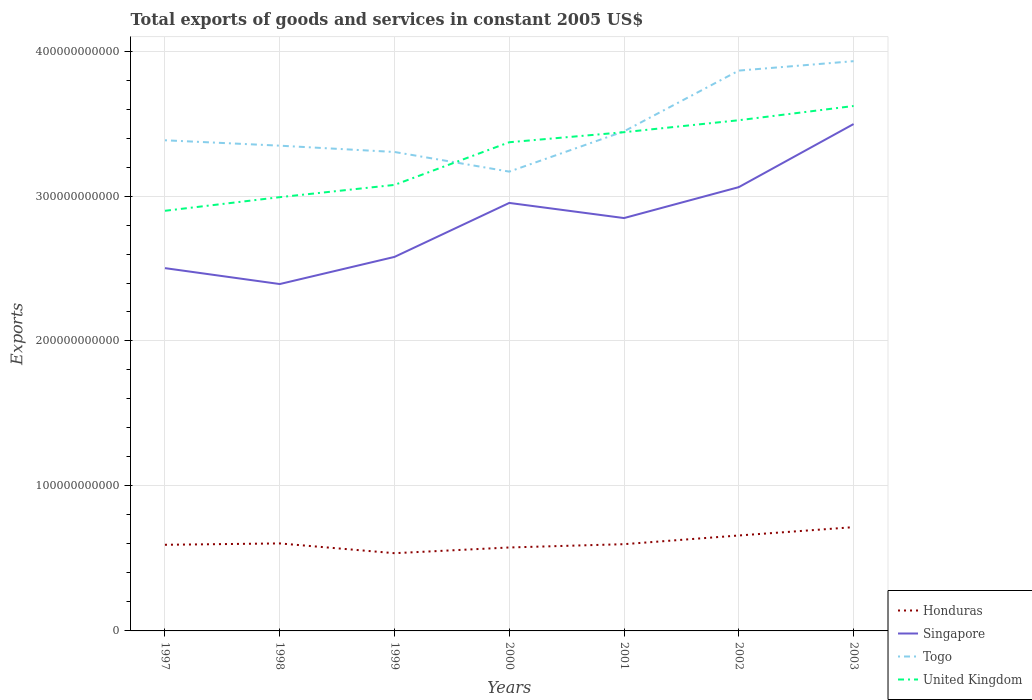Does the line corresponding to Togo intersect with the line corresponding to United Kingdom?
Keep it short and to the point. Yes. Across all years, what is the maximum total exports of goods and services in United Kingdom?
Your response must be concise. 2.90e+11. What is the total total exports of goods and services in Togo in the graph?
Provide a succinct answer. -5.61e+1. What is the difference between the highest and the second highest total exports of goods and services in Singapore?
Your answer should be very brief. 1.10e+11. Is the total exports of goods and services in Honduras strictly greater than the total exports of goods and services in Singapore over the years?
Your answer should be compact. Yes. How many lines are there?
Your response must be concise. 4. How many years are there in the graph?
Provide a short and direct response. 7. What is the difference between two consecutive major ticks on the Y-axis?
Provide a short and direct response. 1.00e+11. Does the graph contain any zero values?
Provide a succinct answer. No. Does the graph contain grids?
Your answer should be compact. Yes. Where does the legend appear in the graph?
Provide a succinct answer. Bottom right. How many legend labels are there?
Make the answer very short. 4. What is the title of the graph?
Your response must be concise. Total exports of goods and services in constant 2005 US$. What is the label or title of the Y-axis?
Offer a terse response. Exports. What is the Exports in Honduras in 1997?
Offer a terse response. 5.94e+1. What is the Exports in Singapore in 1997?
Your answer should be very brief. 2.50e+11. What is the Exports in Togo in 1997?
Your answer should be compact. 3.38e+11. What is the Exports in United Kingdom in 1997?
Provide a succinct answer. 2.90e+11. What is the Exports of Honduras in 1998?
Ensure brevity in your answer.  6.04e+1. What is the Exports of Singapore in 1998?
Keep it short and to the point. 2.39e+11. What is the Exports in Togo in 1998?
Your answer should be compact. 3.35e+11. What is the Exports of United Kingdom in 1998?
Make the answer very short. 2.99e+11. What is the Exports in Honduras in 1999?
Give a very brief answer. 5.36e+1. What is the Exports in Singapore in 1999?
Your answer should be very brief. 2.58e+11. What is the Exports in Togo in 1999?
Offer a very short reply. 3.30e+11. What is the Exports of United Kingdom in 1999?
Ensure brevity in your answer.  3.08e+11. What is the Exports in Honduras in 2000?
Your answer should be very brief. 5.76e+1. What is the Exports in Singapore in 2000?
Ensure brevity in your answer.  2.95e+11. What is the Exports in Togo in 2000?
Provide a short and direct response. 3.17e+11. What is the Exports of United Kingdom in 2000?
Offer a terse response. 3.37e+11. What is the Exports in Honduras in 2001?
Make the answer very short. 5.98e+1. What is the Exports of Singapore in 2001?
Ensure brevity in your answer.  2.85e+11. What is the Exports of Togo in 2001?
Make the answer very short. 3.45e+11. What is the Exports of United Kingdom in 2001?
Offer a very short reply. 3.44e+11. What is the Exports of Honduras in 2002?
Offer a terse response. 6.58e+1. What is the Exports of Singapore in 2002?
Your answer should be very brief. 3.06e+11. What is the Exports of Togo in 2002?
Your answer should be very brief. 3.87e+11. What is the Exports of United Kingdom in 2002?
Your answer should be compact. 3.52e+11. What is the Exports of Honduras in 2003?
Your response must be concise. 7.16e+1. What is the Exports in Singapore in 2003?
Your answer should be compact. 3.50e+11. What is the Exports in Togo in 2003?
Provide a succinct answer. 3.93e+11. What is the Exports of United Kingdom in 2003?
Offer a terse response. 3.62e+11. Across all years, what is the maximum Exports in Honduras?
Your answer should be very brief. 7.16e+1. Across all years, what is the maximum Exports of Singapore?
Make the answer very short. 3.50e+11. Across all years, what is the maximum Exports of Togo?
Give a very brief answer. 3.93e+11. Across all years, what is the maximum Exports in United Kingdom?
Keep it short and to the point. 3.62e+11. Across all years, what is the minimum Exports of Honduras?
Your response must be concise. 5.36e+1. Across all years, what is the minimum Exports in Singapore?
Ensure brevity in your answer.  2.39e+11. Across all years, what is the minimum Exports in Togo?
Give a very brief answer. 3.17e+11. Across all years, what is the minimum Exports in United Kingdom?
Your answer should be compact. 2.90e+11. What is the total Exports of Honduras in the graph?
Provide a succinct answer. 4.28e+11. What is the total Exports of Singapore in the graph?
Offer a very short reply. 1.98e+12. What is the total Exports of Togo in the graph?
Give a very brief answer. 2.44e+12. What is the total Exports of United Kingdom in the graph?
Offer a terse response. 2.29e+12. What is the difference between the Exports of Honduras in 1997 and that in 1998?
Provide a short and direct response. -9.31e+08. What is the difference between the Exports of Singapore in 1997 and that in 1998?
Offer a very short reply. 1.10e+1. What is the difference between the Exports in Togo in 1997 and that in 1998?
Your answer should be very brief. 3.72e+09. What is the difference between the Exports of United Kingdom in 1997 and that in 1998?
Provide a short and direct response. -9.40e+09. What is the difference between the Exports in Honduras in 1997 and that in 1999?
Give a very brief answer. 5.80e+09. What is the difference between the Exports in Singapore in 1997 and that in 1999?
Provide a short and direct response. -7.75e+09. What is the difference between the Exports of Togo in 1997 and that in 1999?
Provide a succinct answer. 8.07e+09. What is the difference between the Exports in United Kingdom in 1997 and that in 1999?
Your answer should be compact. -1.79e+1. What is the difference between the Exports of Honduras in 1997 and that in 2000?
Offer a terse response. 1.86e+09. What is the difference between the Exports of Singapore in 1997 and that in 2000?
Offer a very short reply. -4.50e+1. What is the difference between the Exports of Togo in 1997 and that in 2000?
Your response must be concise. 2.16e+1. What is the difference between the Exports of United Kingdom in 1997 and that in 2000?
Make the answer very short. -4.73e+1. What is the difference between the Exports of Honduras in 1997 and that in 2001?
Your answer should be very brief. -4.18e+08. What is the difference between the Exports of Singapore in 1997 and that in 2001?
Make the answer very short. -3.45e+1. What is the difference between the Exports in Togo in 1997 and that in 2001?
Your answer should be compact. -6.18e+09. What is the difference between the Exports of United Kingdom in 1997 and that in 2001?
Ensure brevity in your answer.  -5.42e+1. What is the difference between the Exports in Honduras in 1997 and that in 2002?
Offer a terse response. -6.41e+09. What is the difference between the Exports in Singapore in 1997 and that in 2002?
Ensure brevity in your answer.  -5.59e+1. What is the difference between the Exports in Togo in 1997 and that in 2002?
Make the answer very short. -4.81e+1. What is the difference between the Exports in United Kingdom in 1997 and that in 2002?
Ensure brevity in your answer.  -6.25e+1. What is the difference between the Exports in Honduras in 1997 and that in 2003?
Ensure brevity in your answer.  -1.22e+1. What is the difference between the Exports of Singapore in 1997 and that in 2003?
Your answer should be very brief. -9.94e+1. What is the difference between the Exports in Togo in 1997 and that in 2003?
Keep it short and to the point. -5.46e+1. What is the difference between the Exports in United Kingdom in 1997 and that in 2003?
Keep it short and to the point. -7.23e+1. What is the difference between the Exports in Honduras in 1998 and that in 1999?
Give a very brief answer. 6.73e+09. What is the difference between the Exports of Singapore in 1998 and that in 1999?
Ensure brevity in your answer.  -1.87e+1. What is the difference between the Exports in Togo in 1998 and that in 1999?
Make the answer very short. 4.35e+09. What is the difference between the Exports of United Kingdom in 1998 and that in 1999?
Keep it short and to the point. -8.45e+09. What is the difference between the Exports in Honduras in 1998 and that in 2000?
Make the answer very short. 2.79e+09. What is the difference between the Exports of Singapore in 1998 and that in 2000?
Make the answer very short. -5.60e+1. What is the difference between the Exports of Togo in 1998 and that in 2000?
Give a very brief answer. 1.79e+1. What is the difference between the Exports in United Kingdom in 1998 and that in 2000?
Your answer should be very brief. -3.79e+1. What is the difference between the Exports of Honduras in 1998 and that in 2001?
Offer a very short reply. 5.13e+08. What is the difference between the Exports in Singapore in 1998 and that in 2001?
Ensure brevity in your answer.  -4.55e+1. What is the difference between the Exports of Togo in 1998 and that in 2001?
Provide a succinct answer. -9.90e+09. What is the difference between the Exports in United Kingdom in 1998 and that in 2001?
Keep it short and to the point. -4.48e+1. What is the difference between the Exports of Honduras in 1998 and that in 2002?
Ensure brevity in your answer.  -5.48e+09. What is the difference between the Exports in Singapore in 1998 and that in 2002?
Offer a very short reply. -6.69e+1. What is the difference between the Exports in Togo in 1998 and that in 2002?
Provide a short and direct response. -5.18e+1. What is the difference between the Exports of United Kingdom in 1998 and that in 2002?
Provide a succinct answer. -5.31e+1. What is the difference between the Exports of Honduras in 1998 and that in 2003?
Provide a short and direct response. -1.12e+1. What is the difference between the Exports of Singapore in 1998 and that in 2003?
Provide a succinct answer. -1.10e+11. What is the difference between the Exports of Togo in 1998 and that in 2003?
Offer a very short reply. -5.83e+1. What is the difference between the Exports of United Kingdom in 1998 and that in 2003?
Offer a terse response. -6.29e+1. What is the difference between the Exports in Honduras in 1999 and that in 2000?
Provide a short and direct response. -3.94e+09. What is the difference between the Exports in Singapore in 1999 and that in 2000?
Provide a succinct answer. -3.72e+1. What is the difference between the Exports of Togo in 1999 and that in 2000?
Give a very brief answer. 1.35e+1. What is the difference between the Exports of United Kingdom in 1999 and that in 2000?
Make the answer very short. -2.94e+1. What is the difference between the Exports of Honduras in 1999 and that in 2001?
Provide a short and direct response. -6.22e+09. What is the difference between the Exports of Singapore in 1999 and that in 2001?
Your response must be concise. -2.68e+1. What is the difference between the Exports of Togo in 1999 and that in 2001?
Make the answer very short. -1.43e+1. What is the difference between the Exports in United Kingdom in 1999 and that in 2001?
Provide a short and direct response. -3.64e+1. What is the difference between the Exports in Honduras in 1999 and that in 2002?
Provide a succinct answer. -1.22e+1. What is the difference between the Exports in Singapore in 1999 and that in 2002?
Your answer should be very brief. -4.81e+1. What is the difference between the Exports in Togo in 1999 and that in 2002?
Offer a terse response. -5.61e+1. What is the difference between the Exports in United Kingdom in 1999 and that in 2002?
Your answer should be compact. -4.46e+1. What is the difference between the Exports of Honduras in 1999 and that in 2003?
Provide a short and direct response. -1.80e+1. What is the difference between the Exports in Singapore in 1999 and that in 2003?
Offer a terse response. -9.16e+1. What is the difference between the Exports in Togo in 1999 and that in 2003?
Make the answer very short. -6.26e+1. What is the difference between the Exports in United Kingdom in 1999 and that in 2003?
Provide a short and direct response. -5.44e+1. What is the difference between the Exports of Honduras in 2000 and that in 2001?
Offer a terse response. -2.28e+09. What is the difference between the Exports of Singapore in 2000 and that in 2001?
Keep it short and to the point. 1.04e+1. What is the difference between the Exports in Togo in 2000 and that in 2001?
Give a very brief answer. -2.78e+1. What is the difference between the Exports in United Kingdom in 2000 and that in 2001?
Make the answer very short. -6.93e+09. What is the difference between the Exports in Honduras in 2000 and that in 2002?
Your response must be concise. -8.27e+09. What is the difference between the Exports in Singapore in 2000 and that in 2002?
Give a very brief answer. -1.09e+1. What is the difference between the Exports of Togo in 2000 and that in 2002?
Keep it short and to the point. -6.97e+1. What is the difference between the Exports of United Kingdom in 2000 and that in 2002?
Offer a terse response. -1.52e+1. What is the difference between the Exports in Honduras in 2000 and that in 2003?
Your answer should be compact. -1.40e+1. What is the difference between the Exports of Singapore in 2000 and that in 2003?
Your answer should be compact. -5.44e+1. What is the difference between the Exports of Togo in 2000 and that in 2003?
Offer a very short reply. -7.62e+1. What is the difference between the Exports of United Kingdom in 2000 and that in 2003?
Your response must be concise. -2.50e+1. What is the difference between the Exports in Honduras in 2001 and that in 2002?
Your answer should be compact. -5.99e+09. What is the difference between the Exports in Singapore in 2001 and that in 2002?
Your answer should be very brief. -2.13e+1. What is the difference between the Exports of Togo in 2001 and that in 2002?
Give a very brief answer. -4.19e+1. What is the difference between the Exports in United Kingdom in 2001 and that in 2002?
Ensure brevity in your answer.  -8.25e+09. What is the difference between the Exports of Honduras in 2001 and that in 2003?
Offer a terse response. -1.17e+1. What is the difference between the Exports in Singapore in 2001 and that in 2003?
Offer a terse response. -6.49e+1. What is the difference between the Exports in Togo in 2001 and that in 2003?
Offer a very short reply. -4.84e+1. What is the difference between the Exports in United Kingdom in 2001 and that in 2003?
Your answer should be very brief. -1.81e+1. What is the difference between the Exports in Honduras in 2002 and that in 2003?
Your answer should be very brief. -5.75e+09. What is the difference between the Exports of Singapore in 2002 and that in 2003?
Offer a very short reply. -4.35e+1. What is the difference between the Exports of Togo in 2002 and that in 2003?
Ensure brevity in your answer.  -6.49e+09. What is the difference between the Exports of United Kingdom in 2002 and that in 2003?
Offer a very short reply. -9.82e+09. What is the difference between the Exports of Honduras in 1997 and the Exports of Singapore in 1998?
Offer a terse response. -1.80e+11. What is the difference between the Exports in Honduras in 1997 and the Exports in Togo in 1998?
Your response must be concise. -2.75e+11. What is the difference between the Exports of Honduras in 1997 and the Exports of United Kingdom in 1998?
Ensure brevity in your answer.  -2.40e+11. What is the difference between the Exports of Singapore in 1997 and the Exports of Togo in 1998?
Keep it short and to the point. -8.45e+1. What is the difference between the Exports in Singapore in 1997 and the Exports in United Kingdom in 1998?
Your answer should be very brief. -4.90e+1. What is the difference between the Exports in Togo in 1997 and the Exports in United Kingdom in 1998?
Provide a short and direct response. 3.92e+1. What is the difference between the Exports in Honduras in 1997 and the Exports in Singapore in 1999?
Ensure brevity in your answer.  -1.99e+11. What is the difference between the Exports in Honduras in 1997 and the Exports in Togo in 1999?
Give a very brief answer. -2.71e+11. What is the difference between the Exports of Honduras in 1997 and the Exports of United Kingdom in 1999?
Give a very brief answer. -2.48e+11. What is the difference between the Exports in Singapore in 1997 and the Exports in Togo in 1999?
Ensure brevity in your answer.  -8.01e+1. What is the difference between the Exports of Singapore in 1997 and the Exports of United Kingdom in 1999?
Offer a terse response. -5.74e+1. What is the difference between the Exports in Togo in 1997 and the Exports in United Kingdom in 1999?
Your answer should be very brief. 3.08e+1. What is the difference between the Exports of Honduras in 1997 and the Exports of Singapore in 2000?
Your response must be concise. -2.36e+11. What is the difference between the Exports in Honduras in 1997 and the Exports in Togo in 2000?
Offer a terse response. -2.57e+11. What is the difference between the Exports in Honduras in 1997 and the Exports in United Kingdom in 2000?
Provide a short and direct response. -2.78e+11. What is the difference between the Exports in Singapore in 1997 and the Exports in Togo in 2000?
Your response must be concise. -6.66e+1. What is the difference between the Exports of Singapore in 1997 and the Exports of United Kingdom in 2000?
Your answer should be very brief. -8.68e+1. What is the difference between the Exports of Togo in 1997 and the Exports of United Kingdom in 2000?
Keep it short and to the point. 1.35e+09. What is the difference between the Exports in Honduras in 1997 and the Exports in Singapore in 2001?
Ensure brevity in your answer.  -2.25e+11. What is the difference between the Exports in Honduras in 1997 and the Exports in Togo in 2001?
Your answer should be compact. -2.85e+11. What is the difference between the Exports of Honduras in 1997 and the Exports of United Kingdom in 2001?
Offer a terse response. -2.85e+11. What is the difference between the Exports of Singapore in 1997 and the Exports of Togo in 2001?
Make the answer very short. -9.44e+1. What is the difference between the Exports of Singapore in 1997 and the Exports of United Kingdom in 2001?
Provide a succinct answer. -9.38e+1. What is the difference between the Exports of Togo in 1997 and the Exports of United Kingdom in 2001?
Keep it short and to the point. -5.58e+09. What is the difference between the Exports in Honduras in 1997 and the Exports in Singapore in 2002?
Keep it short and to the point. -2.47e+11. What is the difference between the Exports in Honduras in 1997 and the Exports in Togo in 2002?
Offer a very short reply. -3.27e+11. What is the difference between the Exports of Honduras in 1997 and the Exports of United Kingdom in 2002?
Your answer should be very brief. -2.93e+11. What is the difference between the Exports of Singapore in 1997 and the Exports of Togo in 2002?
Offer a very short reply. -1.36e+11. What is the difference between the Exports of Singapore in 1997 and the Exports of United Kingdom in 2002?
Your response must be concise. -1.02e+11. What is the difference between the Exports of Togo in 1997 and the Exports of United Kingdom in 2002?
Make the answer very short. -1.38e+1. What is the difference between the Exports in Honduras in 1997 and the Exports in Singapore in 2003?
Provide a short and direct response. -2.90e+11. What is the difference between the Exports in Honduras in 1997 and the Exports in Togo in 2003?
Make the answer very short. -3.34e+11. What is the difference between the Exports in Honduras in 1997 and the Exports in United Kingdom in 2003?
Offer a terse response. -3.03e+11. What is the difference between the Exports in Singapore in 1997 and the Exports in Togo in 2003?
Make the answer very short. -1.43e+11. What is the difference between the Exports of Singapore in 1997 and the Exports of United Kingdom in 2003?
Give a very brief answer. -1.12e+11. What is the difference between the Exports of Togo in 1997 and the Exports of United Kingdom in 2003?
Provide a succinct answer. -2.36e+1. What is the difference between the Exports of Honduras in 1998 and the Exports of Singapore in 1999?
Provide a succinct answer. -1.98e+11. What is the difference between the Exports of Honduras in 1998 and the Exports of Togo in 1999?
Offer a terse response. -2.70e+11. What is the difference between the Exports in Honduras in 1998 and the Exports in United Kingdom in 1999?
Your answer should be compact. -2.47e+11. What is the difference between the Exports in Singapore in 1998 and the Exports in Togo in 1999?
Ensure brevity in your answer.  -9.11e+1. What is the difference between the Exports in Singapore in 1998 and the Exports in United Kingdom in 1999?
Your answer should be compact. -6.84e+1. What is the difference between the Exports of Togo in 1998 and the Exports of United Kingdom in 1999?
Offer a terse response. 2.71e+1. What is the difference between the Exports in Honduras in 1998 and the Exports in Singapore in 2000?
Give a very brief answer. -2.35e+11. What is the difference between the Exports of Honduras in 1998 and the Exports of Togo in 2000?
Your answer should be compact. -2.56e+11. What is the difference between the Exports of Honduras in 1998 and the Exports of United Kingdom in 2000?
Offer a very short reply. -2.77e+11. What is the difference between the Exports in Singapore in 1998 and the Exports in Togo in 2000?
Give a very brief answer. -7.76e+1. What is the difference between the Exports in Singapore in 1998 and the Exports in United Kingdom in 2000?
Give a very brief answer. -9.78e+1. What is the difference between the Exports of Togo in 1998 and the Exports of United Kingdom in 2000?
Give a very brief answer. -2.37e+09. What is the difference between the Exports of Honduras in 1998 and the Exports of Singapore in 2001?
Offer a very short reply. -2.24e+11. What is the difference between the Exports of Honduras in 1998 and the Exports of Togo in 2001?
Your answer should be very brief. -2.84e+11. What is the difference between the Exports of Honduras in 1998 and the Exports of United Kingdom in 2001?
Provide a short and direct response. -2.84e+11. What is the difference between the Exports of Singapore in 1998 and the Exports of Togo in 2001?
Give a very brief answer. -1.05e+11. What is the difference between the Exports in Singapore in 1998 and the Exports in United Kingdom in 2001?
Give a very brief answer. -1.05e+11. What is the difference between the Exports in Togo in 1998 and the Exports in United Kingdom in 2001?
Keep it short and to the point. -9.30e+09. What is the difference between the Exports of Honduras in 1998 and the Exports of Singapore in 2002?
Ensure brevity in your answer.  -2.46e+11. What is the difference between the Exports of Honduras in 1998 and the Exports of Togo in 2002?
Provide a succinct answer. -3.26e+11. What is the difference between the Exports of Honduras in 1998 and the Exports of United Kingdom in 2002?
Your answer should be compact. -2.92e+11. What is the difference between the Exports in Singapore in 1998 and the Exports in Togo in 2002?
Give a very brief answer. -1.47e+11. What is the difference between the Exports in Singapore in 1998 and the Exports in United Kingdom in 2002?
Give a very brief answer. -1.13e+11. What is the difference between the Exports in Togo in 1998 and the Exports in United Kingdom in 2002?
Offer a very short reply. -1.76e+1. What is the difference between the Exports of Honduras in 1998 and the Exports of Singapore in 2003?
Your answer should be compact. -2.89e+11. What is the difference between the Exports of Honduras in 1998 and the Exports of Togo in 2003?
Provide a succinct answer. -3.33e+11. What is the difference between the Exports of Honduras in 1998 and the Exports of United Kingdom in 2003?
Provide a succinct answer. -3.02e+11. What is the difference between the Exports in Singapore in 1998 and the Exports in Togo in 2003?
Offer a very short reply. -1.54e+11. What is the difference between the Exports in Singapore in 1998 and the Exports in United Kingdom in 2003?
Offer a terse response. -1.23e+11. What is the difference between the Exports in Togo in 1998 and the Exports in United Kingdom in 2003?
Your answer should be very brief. -2.74e+1. What is the difference between the Exports of Honduras in 1999 and the Exports of Singapore in 2000?
Provide a short and direct response. -2.42e+11. What is the difference between the Exports in Honduras in 1999 and the Exports in Togo in 2000?
Offer a terse response. -2.63e+11. What is the difference between the Exports in Honduras in 1999 and the Exports in United Kingdom in 2000?
Make the answer very short. -2.83e+11. What is the difference between the Exports of Singapore in 1999 and the Exports of Togo in 2000?
Your answer should be compact. -5.88e+1. What is the difference between the Exports of Singapore in 1999 and the Exports of United Kingdom in 2000?
Ensure brevity in your answer.  -7.91e+1. What is the difference between the Exports in Togo in 1999 and the Exports in United Kingdom in 2000?
Your answer should be very brief. -6.72e+09. What is the difference between the Exports in Honduras in 1999 and the Exports in Singapore in 2001?
Your answer should be very brief. -2.31e+11. What is the difference between the Exports in Honduras in 1999 and the Exports in Togo in 2001?
Your answer should be very brief. -2.91e+11. What is the difference between the Exports in Honduras in 1999 and the Exports in United Kingdom in 2001?
Offer a very short reply. -2.90e+11. What is the difference between the Exports in Singapore in 1999 and the Exports in Togo in 2001?
Your response must be concise. -8.66e+1. What is the difference between the Exports of Singapore in 1999 and the Exports of United Kingdom in 2001?
Keep it short and to the point. -8.60e+1. What is the difference between the Exports in Togo in 1999 and the Exports in United Kingdom in 2001?
Make the answer very short. -1.37e+1. What is the difference between the Exports in Honduras in 1999 and the Exports in Singapore in 2002?
Provide a short and direct response. -2.53e+11. What is the difference between the Exports of Honduras in 1999 and the Exports of Togo in 2002?
Offer a terse response. -3.33e+11. What is the difference between the Exports in Honduras in 1999 and the Exports in United Kingdom in 2002?
Your answer should be very brief. -2.99e+11. What is the difference between the Exports of Singapore in 1999 and the Exports of Togo in 2002?
Your answer should be compact. -1.29e+11. What is the difference between the Exports of Singapore in 1999 and the Exports of United Kingdom in 2002?
Your answer should be very brief. -9.43e+1. What is the difference between the Exports in Togo in 1999 and the Exports in United Kingdom in 2002?
Your response must be concise. -2.19e+1. What is the difference between the Exports of Honduras in 1999 and the Exports of Singapore in 2003?
Your answer should be very brief. -2.96e+11. What is the difference between the Exports in Honduras in 1999 and the Exports in Togo in 2003?
Give a very brief answer. -3.39e+11. What is the difference between the Exports in Honduras in 1999 and the Exports in United Kingdom in 2003?
Offer a terse response. -3.08e+11. What is the difference between the Exports of Singapore in 1999 and the Exports of Togo in 2003?
Provide a succinct answer. -1.35e+11. What is the difference between the Exports of Singapore in 1999 and the Exports of United Kingdom in 2003?
Your answer should be very brief. -1.04e+11. What is the difference between the Exports of Togo in 1999 and the Exports of United Kingdom in 2003?
Give a very brief answer. -3.17e+1. What is the difference between the Exports in Honduras in 2000 and the Exports in Singapore in 2001?
Offer a very short reply. -2.27e+11. What is the difference between the Exports in Honduras in 2000 and the Exports in Togo in 2001?
Offer a terse response. -2.87e+11. What is the difference between the Exports of Honduras in 2000 and the Exports of United Kingdom in 2001?
Offer a terse response. -2.86e+11. What is the difference between the Exports of Singapore in 2000 and the Exports of Togo in 2001?
Your answer should be compact. -4.94e+1. What is the difference between the Exports of Singapore in 2000 and the Exports of United Kingdom in 2001?
Provide a succinct answer. -4.88e+1. What is the difference between the Exports in Togo in 2000 and the Exports in United Kingdom in 2001?
Your answer should be compact. -2.72e+1. What is the difference between the Exports of Honduras in 2000 and the Exports of Singapore in 2002?
Your answer should be very brief. -2.49e+11. What is the difference between the Exports in Honduras in 2000 and the Exports in Togo in 2002?
Your response must be concise. -3.29e+11. What is the difference between the Exports of Honduras in 2000 and the Exports of United Kingdom in 2002?
Offer a terse response. -2.95e+11. What is the difference between the Exports of Singapore in 2000 and the Exports of Togo in 2002?
Your response must be concise. -9.13e+1. What is the difference between the Exports in Singapore in 2000 and the Exports in United Kingdom in 2002?
Give a very brief answer. -5.70e+1. What is the difference between the Exports of Togo in 2000 and the Exports of United Kingdom in 2002?
Keep it short and to the point. -3.54e+1. What is the difference between the Exports of Honduras in 2000 and the Exports of Singapore in 2003?
Offer a very short reply. -2.92e+11. What is the difference between the Exports in Honduras in 2000 and the Exports in Togo in 2003?
Your response must be concise. -3.35e+11. What is the difference between the Exports in Honduras in 2000 and the Exports in United Kingdom in 2003?
Provide a succinct answer. -3.05e+11. What is the difference between the Exports of Singapore in 2000 and the Exports of Togo in 2003?
Your answer should be very brief. -9.78e+1. What is the difference between the Exports in Singapore in 2000 and the Exports in United Kingdom in 2003?
Your response must be concise. -6.69e+1. What is the difference between the Exports in Togo in 2000 and the Exports in United Kingdom in 2003?
Make the answer very short. -4.53e+1. What is the difference between the Exports in Honduras in 2001 and the Exports in Singapore in 2002?
Your answer should be compact. -2.46e+11. What is the difference between the Exports in Honduras in 2001 and the Exports in Togo in 2002?
Offer a terse response. -3.27e+11. What is the difference between the Exports in Honduras in 2001 and the Exports in United Kingdom in 2002?
Your response must be concise. -2.92e+11. What is the difference between the Exports in Singapore in 2001 and the Exports in Togo in 2002?
Provide a succinct answer. -1.02e+11. What is the difference between the Exports in Singapore in 2001 and the Exports in United Kingdom in 2002?
Your answer should be very brief. -6.75e+1. What is the difference between the Exports in Togo in 2001 and the Exports in United Kingdom in 2002?
Offer a very short reply. -7.65e+09. What is the difference between the Exports in Honduras in 2001 and the Exports in Singapore in 2003?
Offer a terse response. -2.90e+11. What is the difference between the Exports in Honduras in 2001 and the Exports in Togo in 2003?
Your response must be concise. -3.33e+11. What is the difference between the Exports in Honduras in 2001 and the Exports in United Kingdom in 2003?
Make the answer very short. -3.02e+11. What is the difference between the Exports of Singapore in 2001 and the Exports of Togo in 2003?
Your answer should be very brief. -1.08e+11. What is the difference between the Exports of Singapore in 2001 and the Exports of United Kingdom in 2003?
Keep it short and to the point. -7.73e+1. What is the difference between the Exports of Togo in 2001 and the Exports of United Kingdom in 2003?
Ensure brevity in your answer.  -1.75e+1. What is the difference between the Exports in Honduras in 2002 and the Exports in Singapore in 2003?
Keep it short and to the point. -2.84e+11. What is the difference between the Exports of Honduras in 2002 and the Exports of Togo in 2003?
Keep it short and to the point. -3.27e+11. What is the difference between the Exports in Honduras in 2002 and the Exports in United Kingdom in 2003?
Make the answer very short. -2.96e+11. What is the difference between the Exports in Singapore in 2002 and the Exports in Togo in 2003?
Your response must be concise. -8.69e+1. What is the difference between the Exports of Singapore in 2002 and the Exports of United Kingdom in 2003?
Offer a very short reply. -5.60e+1. What is the difference between the Exports of Togo in 2002 and the Exports of United Kingdom in 2003?
Provide a short and direct response. 2.44e+1. What is the average Exports in Honduras per year?
Provide a succinct answer. 6.12e+1. What is the average Exports of Singapore per year?
Ensure brevity in your answer.  2.83e+11. What is the average Exports of Togo per year?
Your answer should be compact. 3.49e+11. What is the average Exports in United Kingdom per year?
Provide a succinct answer. 3.27e+11. In the year 1997, what is the difference between the Exports in Honduras and Exports in Singapore?
Ensure brevity in your answer.  -1.91e+11. In the year 1997, what is the difference between the Exports in Honduras and Exports in Togo?
Keep it short and to the point. -2.79e+11. In the year 1997, what is the difference between the Exports in Honduras and Exports in United Kingdom?
Ensure brevity in your answer.  -2.30e+11. In the year 1997, what is the difference between the Exports of Singapore and Exports of Togo?
Keep it short and to the point. -8.82e+1. In the year 1997, what is the difference between the Exports of Singapore and Exports of United Kingdom?
Keep it short and to the point. -3.96e+1. In the year 1997, what is the difference between the Exports of Togo and Exports of United Kingdom?
Make the answer very short. 4.86e+1. In the year 1998, what is the difference between the Exports in Honduras and Exports in Singapore?
Your answer should be very brief. -1.79e+11. In the year 1998, what is the difference between the Exports of Honduras and Exports of Togo?
Your answer should be compact. -2.74e+11. In the year 1998, what is the difference between the Exports in Honduras and Exports in United Kingdom?
Your answer should be very brief. -2.39e+11. In the year 1998, what is the difference between the Exports in Singapore and Exports in Togo?
Give a very brief answer. -9.55e+1. In the year 1998, what is the difference between the Exports of Singapore and Exports of United Kingdom?
Provide a succinct answer. -5.99e+1. In the year 1998, what is the difference between the Exports of Togo and Exports of United Kingdom?
Provide a short and direct response. 3.55e+1. In the year 1999, what is the difference between the Exports of Honduras and Exports of Singapore?
Make the answer very short. -2.04e+11. In the year 1999, what is the difference between the Exports in Honduras and Exports in Togo?
Your answer should be compact. -2.77e+11. In the year 1999, what is the difference between the Exports in Honduras and Exports in United Kingdom?
Your answer should be compact. -2.54e+11. In the year 1999, what is the difference between the Exports in Singapore and Exports in Togo?
Keep it short and to the point. -7.24e+1. In the year 1999, what is the difference between the Exports in Singapore and Exports in United Kingdom?
Give a very brief answer. -4.97e+1. In the year 1999, what is the difference between the Exports in Togo and Exports in United Kingdom?
Ensure brevity in your answer.  2.27e+1. In the year 2000, what is the difference between the Exports in Honduras and Exports in Singapore?
Offer a very short reply. -2.38e+11. In the year 2000, what is the difference between the Exports in Honduras and Exports in Togo?
Your answer should be compact. -2.59e+11. In the year 2000, what is the difference between the Exports in Honduras and Exports in United Kingdom?
Offer a terse response. -2.80e+11. In the year 2000, what is the difference between the Exports of Singapore and Exports of Togo?
Your answer should be compact. -2.16e+1. In the year 2000, what is the difference between the Exports in Singapore and Exports in United Kingdom?
Your response must be concise. -4.19e+1. In the year 2000, what is the difference between the Exports of Togo and Exports of United Kingdom?
Ensure brevity in your answer.  -2.03e+1. In the year 2001, what is the difference between the Exports of Honduras and Exports of Singapore?
Your answer should be very brief. -2.25e+11. In the year 2001, what is the difference between the Exports in Honduras and Exports in Togo?
Provide a succinct answer. -2.85e+11. In the year 2001, what is the difference between the Exports of Honduras and Exports of United Kingdom?
Provide a short and direct response. -2.84e+11. In the year 2001, what is the difference between the Exports of Singapore and Exports of Togo?
Offer a terse response. -5.98e+1. In the year 2001, what is the difference between the Exports of Singapore and Exports of United Kingdom?
Give a very brief answer. -5.92e+1. In the year 2001, what is the difference between the Exports in Togo and Exports in United Kingdom?
Give a very brief answer. 5.97e+08. In the year 2002, what is the difference between the Exports of Honduras and Exports of Singapore?
Ensure brevity in your answer.  -2.40e+11. In the year 2002, what is the difference between the Exports in Honduras and Exports in Togo?
Your answer should be very brief. -3.21e+11. In the year 2002, what is the difference between the Exports of Honduras and Exports of United Kingdom?
Your answer should be compact. -2.86e+11. In the year 2002, what is the difference between the Exports of Singapore and Exports of Togo?
Make the answer very short. -8.04e+1. In the year 2002, what is the difference between the Exports of Singapore and Exports of United Kingdom?
Provide a succinct answer. -4.61e+1. In the year 2002, what is the difference between the Exports of Togo and Exports of United Kingdom?
Make the answer very short. 3.42e+1. In the year 2003, what is the difference between the Exports of Honduras and Exports of Singapore?
Make the answer very short. -2.78e+11. In the year 2003, what is the difference between the Exports of Honduras and Exports of Togo?
Offer a very short reply. -3.21e+11. In the year 2003, what is the difference between the Exports of Honduras and Exports of United Kingdom?
Make the answer very short. -2.91e+11. In the year 2003, what is the difference between the Exports in Singapore and Exports in Togo?
Your answer should be compact. -4.34e+1. In the year 2003, what is the difference between the Exports in Singapore and Exports in United Kingdom?
Ensure brevity in your answer.  -1.25e+1. In the year 2003, what is the difference between the Exports of Togo and Exports of United Kingdom?
Keep it short and to the point. 3.09e+1. What is the ratio of the Exports in Honduras in 1997 to that in 1998?
Provide a short and direct response. 0.98. What is the ratio of the Exports of Singapore in 1997 to that in 1998?
Provide a succinct answer. 1.05. What is the ratio of the Exports of Togo in 1997 to that in 1998?
Your answer should be very brief. 1.01. What is the ratio of the Exports of United Kingdom in 1997 to that in 1998?
Your answer should be compact. 0.97. What is the ratio of the Exports of Honduras in 1997 to that in 1999?
Give a very brief answer. 1.11. What is the ratio of the Exports of Togo in 1997 to that in 1999?
Offer a very short reply. 1.02. What is the ratio of the Exports of United Kingdom in 1997 to that in 1999?
Your answer should be compact. 0.94. What is the ratio of the Exports of Honduras in 1997 to that in 2000?
Make the answer very short. 1.03. What is the ratio of the Exports of Singapore in 1997 to that in 2000?
Keep it short and to the point. 0.85. What is the ratio of the Exports in Togo in 1997 to that in 2000?
Make the answer very short. 1.07. What is the ratio of the Exports in United Kingdom in 1997 to that in 2000?
Ensure brevity in your answer.  0.86. What is the ratio of the Exports in Singapore in 1997 to that in 2001?
Your response must be concise. 0.88. What is the ratio of the Exports in Togo in 1997 to that in 2001?
Give a very brief answer. 0.98. What is the ratio of the Exports in United Kingdom in 1997 to that in 2001?
Your response must be concise. 0.84. What is the ratio of the Exports of Honduras in 1997 to that in 2002?
Make the answer very short. 0.9. What is the ratio of the Exports of Singapore in 1997 to that in 2002?
Ensure brevity in your answer.  0.82. What is the ratio of the Exports of Togo in 1997 to that in 2002?
Your response must be concise. 0.88. What is the ratio of the Exports of United Kingdom in 1997 to that in 2002?
Provide a short and direct response. 0.82. What is the ratio of the Exports of Honduras in 1997 to that in 2003?
Offer a very short reply. 0.83. What is the ratio of the Exports in Singapore in 1997 to that in 2003?
Provide a succinct answer. 0.72. What is the ratio of the Exports of Togo in 1997 to that in 2003?
Keep it short and to the point. 0.86. What is the ratio of the Exports of United Kingdom in 1997 to that in 2003?
Make the answer very short. 0.8. What is the ratio of the Exports in Honduras in 1998 to that in 1999?
Offer a very short reply. 1.13. What is the ratio of the Exports in Singapore in 1998 to that in 1999?
Make the answer very short. 0.93. What is the ratio of the Exports of Togo in 1998 to that in 1999?
Provide a short and direct response. 1.01. What is the ratio of the Exports in United Kingdom in 1998 to that in 1999?
Offer a terse response. 0.97. What is the ratio of the Exports in Honduras in 1998 to that in 2000?
Give a very brief answer. 1.05. What is the ratio of the Exports in Singapore in 1998 to that in 2000?
Ensure brevity in your answer.  0.81. What is the ratio of the Exports in Togo in 1998 to that in 2000?
Keep it short and to the point. 1.06. What is the ratio of the Exports of United Kingdom in 1998 to that in 2000?
Ensure brevity in your answer.  0.89. What is the ratio of the Exports in Honduras in 1998 to that in 2001?
Your response must be concise. 1.01. What is the ratio of the Exports of Singapore in 1998 to that in 2001?
Offer a terse response. 0.84. What is the ratio of the Exports in Togo in 1998 to that in 2001?
Your answer should be very brief. 0.97. What is the ratio of the Exports in United Kingdom in 1998 to that in 2001?
Offer a terse response. 0.87. What is the ratio of the Exports in Honduras in 1998 to that in 2002?
Offer a very short reply. 0.92. What is the ratio of the Exports in Singapore in 1998 to that in 2002?
Your response must be concise. 0.78. What is the ratio of the Exports in Togo in 1998 to that in 2002?
Provide a succinct answer. 0.87. What is the ratio of the Exports of United Kingdom in 1998 to that in 2002?
Give a very brief answer. 0.85. What is the ratio of the Exports in Honduras in 1998 to that in 2003?
Make the answer very short. 0.84. What is the ratio of the Exports of Singapore in 1998 to that in 2003?
Ensure brevity in your answer.  0.68. What is the ratio of the Exports of Togo in 1998 to that in 2003?
Your response must be concise. 0.85. What is the ratio of the Exports of United Kingdom in 1998 to that in 2003?
Make the answer very short. 0.83. What is the ratio of the Exports in Honduras in 1999 to that in 2000?
Offer a very short reply. 0.93. What is the ratio of the Exports in Singapore in 1999 to that in 2000?
Your answer should be very brief. 0.87. What is the ratio of the Exports of Togo in 1999 to that in 2000?
Make the answer very short. 1.04. What is the ratio of the Exports in United Kingdom in 1999 to that in 2000?
Keep it short and to the point. 0.91. What is the ratio of the Exports in Honduras in 1999 to that in 2001?
Ensure brevity in your answer.  0.9. What is the ratio of the Exports in Singapore in 1999 to that in 2001?
Keep it short and to the point. 0.91. What is the ratio of the Exports of Togo in 1999 to that in 2001?
Give a very brief answer. 0.96. What is the ratio of the Exports in United Kingdom in 1999 to that in 2001?
Ensure brevity in your answer.  0.89. What is the ratio of the Exports in Honduras in 1999 to that in 2002?
Ensure brevity in your answer.  0.81. What is the ratio of the Exports in Singapore in 1999 to that in 2002?
Provide a succinct answer. 0.84. What is the ratio of the Exports of Togo in 1999 to that in 2002?
Your answer should be compact. 0.85. What is the ratio of the Exports in United Kingdom in 1999 to that in 2002?
Make the answer very short. 0.87. What is the ratio of the Exports of Honduras in 1999 to that in 2003?
Make the answer very short. 0.75. What is the ratio of the Exports of Singapore in 1999 to that in 2003?
Ensure brevity in your answer.  0.74. What is the ratio of the Exports in Togo in 1999 to that in 2003?
Provide a short and direct response. 0.84. What is the ratio of the Exports of United Kingdom in 1999 to that in 2003?
Make the answer very short. 0.85. What is the ratio of the Exports in Honduras in 2000 to that in 2001?
Provide a succinct answer. 0.96. What is the ratio of the Exports of Singapore in 2000 to that in 2001?
Keep it short and to the point. 1.04. What is the ratio of the Exports in Togo in 2000 to that in 2001?
Offer a very short reply. 0.92. What is the ratio of the Exports in United Kingdom in 2000 to that in 2001?
Keep it short and to the point. 0.98. What is the ratio of the Exports of Honduras in 2000 to that in 2002?
Offer a terse response. 0.87. What is the ratio of the Exports of Singapore in 2000 to that in 2002?
Provide a short and direct response. 0.96. What is the ratio of the Exports in Togo in 2000 to that in 2002?
Ensure brevity in your answer.  0.82. What is the ratio of the Exports of United Kingdom in 2000 to that in 2002?
Ensure brevity in your answer.  0.96. What is the ratio of the Exports in Honduras in 2000 to that in 2003?
Your response must be concise. 0.8. What is the ratio of the Exports in Singapore in 2000 to that in 2003?
Keep it short and to the point. 0.84. What is the ratio of the Exports of Togo in 2000 to that in 2003?
Ensure brevity in your answer.  0.81. What is the ratio of the Exports of Honduras in 2001 to that in 2002?
Your response must be concise. 0.91. What is the ratio of the Exports of Singapore in 2001 to that in 2002?
Ensure brevity in your answer.  0.93. What is the ratio of the Exports in Togo in 2001 to that in 2002?
Offer a very short reply. 0.89. What is the ratio of the Exports in United Kingdom in 2001 to that in 2002?
Your response must be concise. 0.98. What is the ratio of the Exports of Honduras in 2001 to that in 2003?
Provide a succinct answer. 0.84. What is the ratio of the Exports of Singapore in 2001 to that in 2003?
Provide a succinct answer. 0.81. What is the ratio of the Exports in Togo in 2001 to that in 2003?
Give a very brief answer. 0.88. What is the ratio of the Exports of United Kingdom in 2001 to that in 2003?
Offer a terse response. 0.95. What is the ratio of the Exports in Honduras in 2002 to that in 2003?
Offer a very short reply. 0.92. What is the ratio of the Exports of Singapore in 2002 to that in 2003?
Make the answer very short. 0.88. What is the ratio of the Exports in Togo in 2002 to that in 2003?
Your response must be concise. 0.98. What is the ratio of the Exports in United Kingdom in 2002 to that in 2003?
Your answer should be very brief. 0.97. What is the difference between the highest and the second highest Exports of Honduras?
Offer a terse response. 5.75e+09. What is the difference between the highest and the second highest Exports of Singapore?
Provide a short and direct response. 4.35e+1. What is the difference between the highest and the second highest Exports of Togo?
Keep it short and to the point. 6.49e+09. What is the difference between the highest and the second highest Exports in United Kingdom?
Keep it short and to the point. 9.82e+09. What is the difference between the highest and the lowest Exports in Honduras?
Your answer should be very brief. 1.80e+1. What is the difference between the highest and the lowest Exports of Singapore?
Your response must be concise. 1.10e+11. What is the difference between the highest and the lowest Exports in Togo?
Ensure brevity in your answer.  7.62e+1. What is the difference between the highest and the lowest Exports in United Kingdom?
Offer a very short reply. 7.23e+1. 